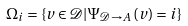Convert formula to latex. <formula><loc_0><loc_0><loc_500><loc_500>\Omega _ { i } = \left \{ v \in \mathcal { D } | \Psi _ { \mathcal { D } \rightarrow A } \left ( v \right ) = i \right \}</formula> 